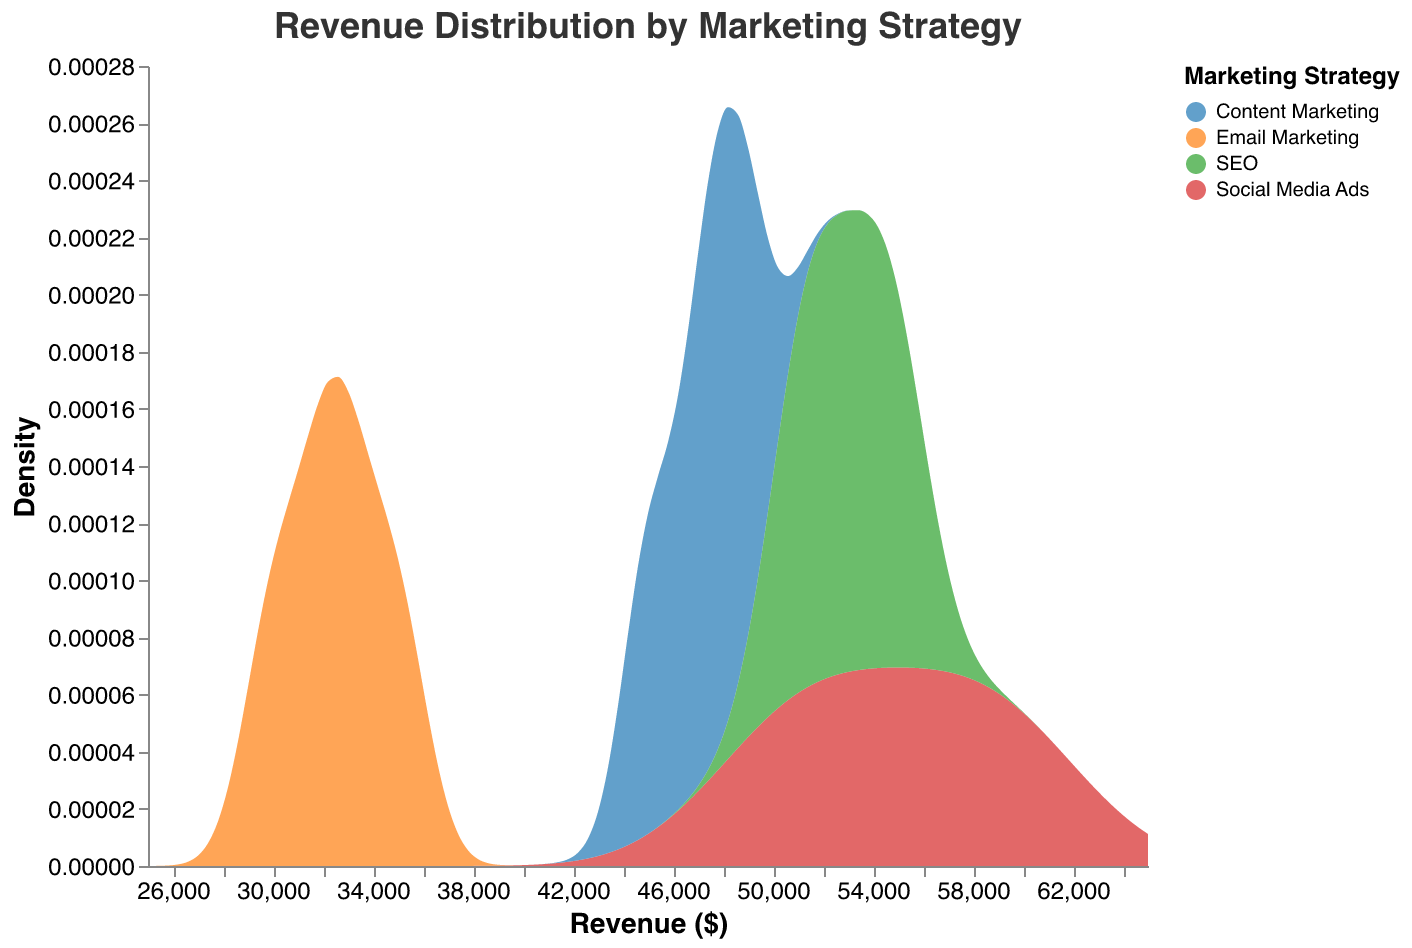What is the title of the chart? The title of the chart is displayed at the top and reads "Revenue Distribution by Marketing Strategy".
Answer: Revenue Distribution by Marketing Strategy What is the color associated with 'SEO'? The color coding for each strategy can be found in the legend. For 'SEO,' it is the fourth item in the legend and it is red.
Answer: red Which marketing strategy shows the highest density at approximately $55,000 in revenue? By observing the density curves, 'Social Media Ads' has a prominent density peak around the $55,000 mark.
Answer: Social Media Ads What is the revenue range covered by the data? The x-axis, labeled "Revenue ($)," spans from $25,000 to $65,000, indicating the range of revenue values.
Answer: $25,000 to $65,000 Which marketing strategy appears to generate the lowest revenue? Looking at the density peaks and x-axis values, 'Email Marketing' consistently shows peaks at lower revenue values compared to others.
Answer: Email Marketing How does the revenue distribution for 'Content Marketing' compare to 'SEO'? By comparing the density curves of 'Content Marketing' and 'SEO,' 'SEO' tends to have its density peaks at slightly higher revenue values than 'Content Marketing.'
Answer: SEO has slightly higher revenue peaks Which marketing strategy shows the widest spread in revenue distribution? By assessing the widths of the density curves, 'Social Media Ads' appears to have the broadest spread, covering a wider range of revenue values from approximately $50,000 to $60,000.
Answer: Social Media Ads At what revenue value do 'Content Marketing' and 'Email Marketing' intersect in density? Observing the density curves, 'Content Marketing' and 'Email Marketing' intersect around the $33,000 to $35,000 revenue mark.
Answer: $33,000 to $35,000 Which marketing strategy demonstrates the most concentrated revenue distribution? By looking at the density curves, 'SEO' has a noticeable concentration around the $50,000 to $55,000 revenue range, showing a less spread-out distribution.
Answer: SEO 